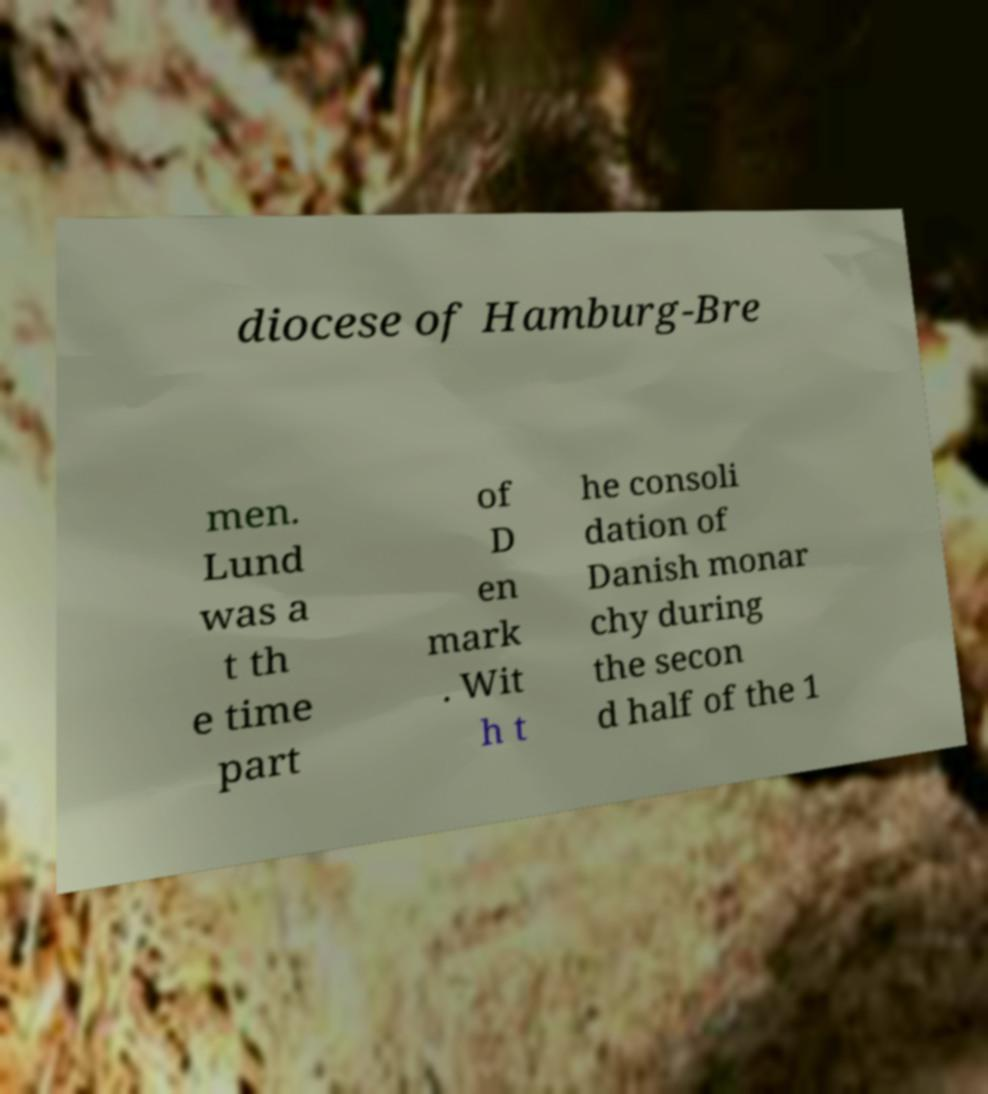Can you read and provide the text displayed in the image?This photo seems to have some interesting text. Can you extract and type it out for me? diocese of Hamburg-Bre men. Lund was a t th e time part of D en mark . Wit h t he consoli dation of Danish monar chy during the secon d half of the 1 